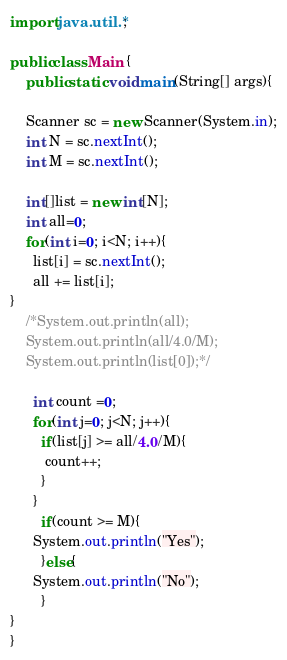Convert code to text. <code><loc_0><loc_0><loc_500><loc_500><_Java_>import java.util.*;

public class Main {
    public static void main(String[] args){
    
    Scanner sc = new Scanner(System.in);
    int N = sc.nextInt();
    int M = sc.nextInt();

    int[]list = new int[N];
    int all=0;
    for(int i=0; i<N; i++){
	  list[i] = sc.nextInt();	
      all += list[i];
}  
    /*System.out.println(all);
    System.out.println(all/4.0/M);
	System.out.println(list[0]);*/

      int count =0;
      for(int j=0; j<N; j++){
        if(list[j] >= all/4.0/M){
         count++;
        }
      }
		if(count >= M){
      System.out.println("Yes");
        }else{
      System.out.println("No");
        }
}
}</code> 